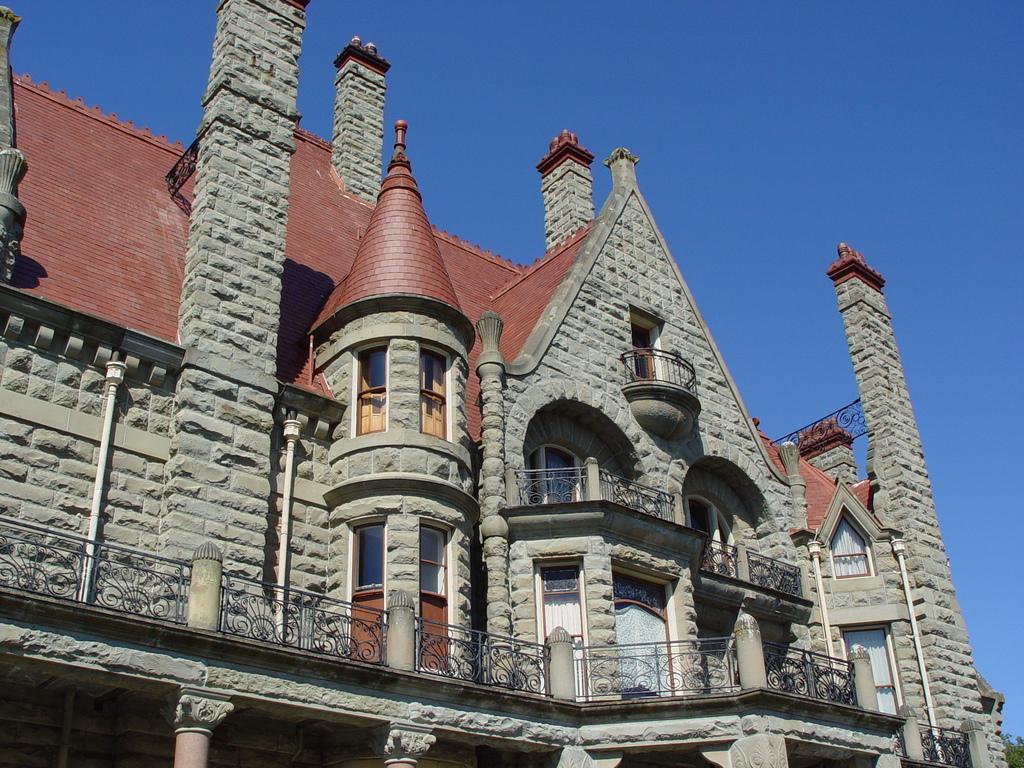How would you summarize this image in a sentence or two? In this image I can see a building in brown and gray color, background the sky is in blue color. 